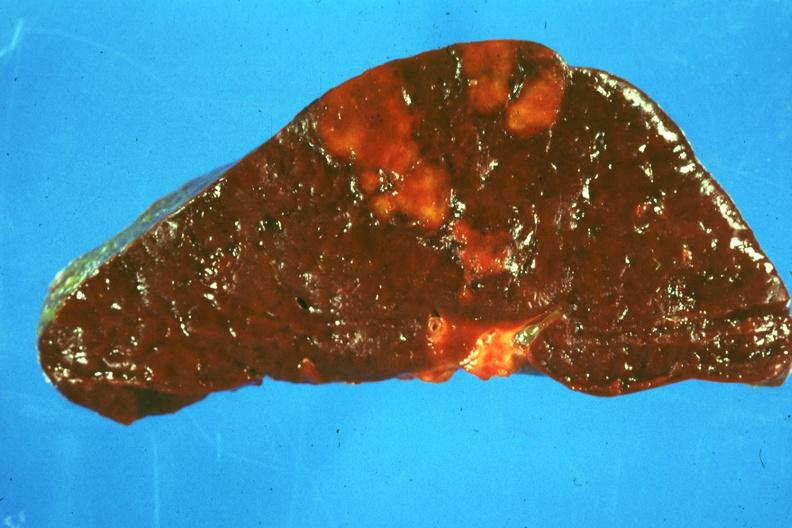s spleen present?
Answer the question using a single word or phrase. Yes 